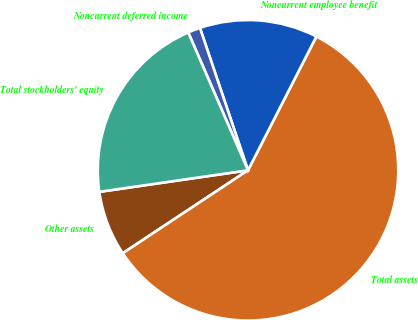Convert chart to OTSL. <chart><loc_0><loc_0><loc_500><loc_500><pie_chart><fcel>Other assets<fcel>Total assets<fcel>Noncurrent employee benefit<fcel>Noncurrent deferred income<fcel>Total stockholders' equity<nl><fcel>7.02%<fcel>58.17%<fcel>12.7%<fcel>1.33%<fcel>20.78%<nl></chart> 